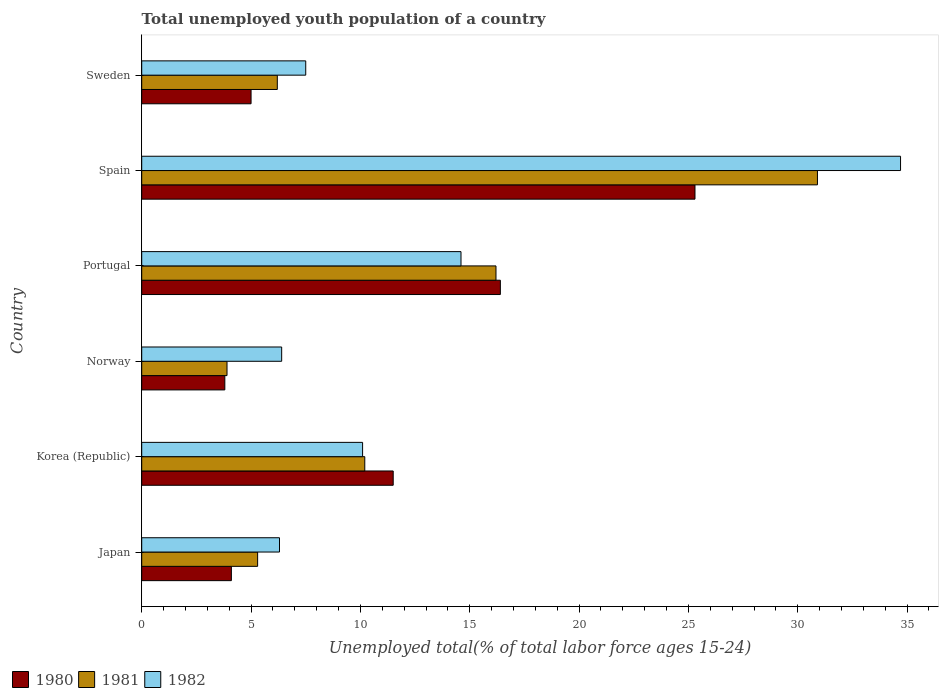Are the number of bars on each tick of the Y-axis equal?
Your answer should be compact. Yes. What is the label of the 2nd group of bars from the top?
Ensure brevity in your answer.  Spain. In how many cases, is the number of bars for a given country not equal to the number of legend labels?
Ensure brevity in your answer.  0. What is the percentage of total unemployed youth population of a country in 1980 in Spain?
Make the answer very short. 25.3. Across all countries, what is the maximum percentage of total unemployed youth population of a country in 1980?
Your answer should be compact. 25.3. Across all countries, what is the minimum percentage of total unemployed youth population of a country in 1981?
Make the answer very short. 3.9. In which country was the percentage of total unemployed youth population of a country in 1981 minimum?
Make the answer very short. Norway. What is the total percentage of total unemployed youth population of a country in 1981 in the graph?
Ensure brevity in your answer.  72.7. What is the difference between the percentage of total unemployed youth population of a country in 1980 in Norway and that in Sweden?
Provide a short and direct response. -1.2. What is the difference between the percentage of total unemployed youth population of a country in 1980 in Japan and the percentage of total unemployed youth population of a country in 1981 in Korea (Republic)?
Your answer should be compact. -6.1. What is the average percentage of total unemployed youth population of a country in 1981 per country?
Ensure brevity in your answer.  12.12. What is the difference between the percentage of total unemployed youth population of a country in 1981 and percentage of total unemployed youth population of a country in 1980 in Sweden?
Offer a very short reply. 1.2. In how many countries, is the percentage of total unemployed youth population of a country in 1982 greater than 3 %?
Make the answer very short. 6. What is the ratio of the percentage of total unemployed youth population of a country in 1981 in Japan to that in Norway?
Your answer should be compact. 1.36. What is the difference between the highest and the second highest percentage of total unemployed youth population of a country in 1980?
Provide a short and direct response. 8.9. What is the difference between the highest and the lowest percentage of total unemployed youth population of a country in 1981?
Provide a succinct answer. 27. In how many countries, is the percentage of total unemployed youth population of a country in 1981 greater than the average percentage of total unemployed youth population of a country in 1981 taken over all countries?
Your answer should be compact. 2. Is the sum of the percentage of total unemployed youth population of a country in 1981 in Norway and Spain greater than the maximum percentage of total unemployed youth population of a country in 1980 across all countries?
Offer a terse response. Yes. What does the 2nd bar from the top in Japan represents?
Your answer should be very brief. 1981. How many bars are there?
Offer a very short reply. 18. Are all the bars in the graph horizontal?
Ensure brevity in your answer.  Yes. Are the values on the major ticks of X-axis written in scientific E-notation?
Your response must be concise. No. Does the graph contain grids?
Provide a short and direct response. No. Where does the legend appear in the graph?
Keep it short and to the point. Bottom left. How are the legend labels stacked?
Offer a very short reply. Horizontal. What is the title of the graph?
Your answer should be very brief. Total unemployed youth population of a country. What is the label or title of the X-axis?
Offer a very short reply. Unemployed total(% of total labor force ages 15-24). What is the Unemployed total(% of total labor force ages 15-24) in 1980 in Japan?
Your answer should be very brief. 4.1. What is the Unemployed total(% of total labor force ages 15-24) in 1981 in Japan?
Your response must be concise. 5.3. What is the Unemployed total(% of total labor force ages 15-24) of 1982 in Japan?
Make the answer very short. 6.3. What is the Unemployed total(% of total labor force ages 15-24) of 1980 in Korea (Republic)?
Offer a very short reply. 11.5. What is the Unemployed total(% of total labor force ages 15-24) of 1981 in Korea (Republic)?
Provide a short and direct response. 10.2. What is the Unemployed total(% of total labor force ages 15-24) of 1982 in Korea (Republic)?
Your answer should be compact. 10.1. What is the Unemployed total(% of total labor force ages 15-24) of 1980 in Norway?
Give a very brief answer. 3.8. What is the Unemployed total(% of total labor force ages 15-24) of 1981 in Norway?
Offer a very short reply. 3.9. What is the Unemployed total(% of total labor force ages 15-24) of 1982 in Norway?
Your answer should be compact. 6.4. What is the Unemployed total(% of total labor force ages 15-24) of 1980 in Portugal?
Your answer should be compact. 16.4. What is the Unemployed total(% of total labor force ages 15-24) in 1981 in Portugal?
Your response must be concise. 16.2. What is the Unemployed total(% of total labor force ages 15-24) in 1982 in Portugal?
Provide a short and direct response. 14.6. What is the Unemployed total(% of total labor force ages 15-24) in 1980 in Spain?
Give a very brief answer. 25.3. What is the Unemployed total(% of total labor force ages 15-24) in 1981 in Spain?
Ensure brevity in your answer.  30.9. What is the Unemployed total(% of total labor force ages 15-24) of 1982 in Spain?
Make the answer very short. 34.7. What is the Unemployed total(% of total labor force ages 15-24) of 1981 in Sweden?
Give a very brief answer. 6.2. What is the Unemployed total(% of total labor force ages 15-24) of 1982 in Sweden?
Give a very brief answer. 7.5. Across all countries, what is the maximum Unemployed total(% of total labor force ages 15-24) in 1980?
Offer a very short reply. 25.3. Across all countries, what is the maximum Unemployed total(% of total labor force ages 15-24) in 1981?
Keep it short and to the point. 30.9. Across all countries, what is the maximum Unemployed total(% of total labor force ages 15-24) in 1982?
Your answer should be compact. 34.7. Across all countries, what is the minimum Unemployed total(% of total labor force ages 15-24) in 1980?
Your response must be concise. 3.8. Across all countries, what is the minimum Unemployed total(% of total labor force ages 15-24) of 1981?
Your answer should be very brief. 3.9. Across all countries, what is the minimum Unemployed total(% of total labor force ages 15-24) of 1982?
Provide a short and direct response. 6.3. What is the total Unemployed total(% of total labor force ages 15-24) of 1980 in the graph?
Your answer should be very brief. 66.1. What is the total Unemployed total(% of total labor force ages 15-24) of 1981 in the graph?
Keep it short and to the point. 72.7. What is the total Unemployed total(% of total labor force ages 15-24) in 1982 in the graph?
Offer a terse response. 79.6. What is the difference between the Unemployed total(% of total labor force ages 15-24) in 1980 in Japan and that in Korea (Republic)?
Offer a terse response. -7.4. What is the difference between the Unemployed total(% of total labor force ages 15-24) in 1982 in Japan and that in Korea (Republic)?
Your answer should be compact. -3.8. What is the difference between the Unemployed total(% of total labor force ages 15-24) in 1980 in Japan and that in Norway?
Ensure brevity in your answer.  0.3. What is the difference between the Unemployed total(% of total labor force ages 15-24) of 1981 in Japan and that in Norway?
Offer a very short reply. 1.4. What is the difference between the Unemployed total(% of total labor force ages 15-24) of 1982 in Japan and that in Norway?
Your answer should be very brief. -0.1. What is the difference between the Unemployed total(% of total labor force ages 15-24) in 1982 in Japan and that in Portugal?
Your answer should be very brief. -8.3. What is the difference between the Unemployed total(% of total labor force ages 15-24) in 1980 in Japan and that in Spain?
Keep it short and to the point. -21.2. What is the difference between the Unemployed total(% of total labor force ages 15-24) of 1981 in Japan and that in Spain?
Make the answer very short. -25.6. What is the difference between the Unemployed total(% of total labor force ages 15-24) in 1982 in Japan and that in Spain?
Provide a succinct answer. -28.4. What is the difference between the Unemployed total(% of total labor force ages 15-24) of 1981 in Japan and that in Sweden?
Give a very brief answer. -0.9. What is the difference between the Unemployed total(% of total labor force ages 15-24) in 1981 in Korea (Republic) and that in Norway?
Offer a terse response. 6.3. What is the difference between the Unemployed total(% of total labor force ages 15-24) in 1982 in Korea (Republic) and that in Norway?
Ensure brevity in your answer.  3.7. What is the difference between the Unemployed total(% of total labor force ages 15-24) in 1982 in Korea (Republic) and that in Portugal?
Offer a very short reply. -4.5. What is the difference between the Unemployed total(% of total labor force ages 15-24) of 1981 in Korea (Republic) and that in Spain?
Provide a short and direct response. -20.7. What is the difference between the Unemployed total(% of total labor force ages 15-24) in 1982 in Korea (Republic) and that in Spain?
Ensure brevity in your answer.  -24.6. What is the difference between the Unemployed total(% of total labor force ages 15-24) of 1980 in Korea (Republic) and that in Sweden?
Offer a very short reply. 6.5. What is the difference between the Unemployed total(% of total labor force ages 15-24) in 1981 in Korea (Republic) and that in Sweden?
Your answer should be compact. 4. What is the difference between the Unemployed total(% of total labor force ages 15-24) in 1982 in Korea (Republic) and that in Sweden?
Provide a succinct answer. 2.6. What is the difference between the Unemployed total(% of total labor force ages 15-24) of 1980 in Norway and that in Portugal?
Provide a succinct answer. -12.6. What is the difference between the Unemployed total(% of total labor force ages 15-24) of 1981 in Norway and that in Portugal?
Ensure brevity in your answer.  -12.3. What is the difference between the Unemployed total(% of total labor force ages 15-24) of 1982 in Norway and that in Portugal?
Offer a very short reply. -8.2. What is the difference between the Unemployed total(% of total labor force ages 15-24) in 1980 in Norway and that in Spain?
Ensure brevity in your answer.  -21.5. What is the difference between the Unemployed total(% of total labor force ages 15-24) in 1982 in Norway and that in Spain?
Provide a short and direct response. -28.3. What is the difference between the Unemployed total(% of total labor force ages 15-24) of 1980 in Norway and that in Sweden?
Your response must be concise. -1.2. What is the difference between the Unemployed total(% of total labor force ages 15-24) of 1980 in Portugal and that in Spain?
Keep it short and to the point. -8.9. What is the difference between the Unemployed total(% of total labor force ages 15-24) of 1981 in Portugal and that in Spain?
Provide a short and direct response. -14.7. What is the difference between the Unemployed total(% of total labor force ages 15-24) in 1982 in Portugal and that in Spain?
Offer a terse response. -20.1. What is the difference between the Unemployed total(% of total labor force ages 15-24) of 1981 in Portugal and that in Sweden?
Keep it short and to the point. 10. What is the difference between the Unemployed total(% of total labor force ages 15-24) in 1980 in Spain and that in Sweden?
Give a very brief answer. 20.3. What is the difference between the Unemployed total(% of total labor force ages 15-24) in 1981 in Spain and that in Sweden?
Your response must be concise. 24.7. What is the difference between the Unemployed total(% of total labor force ages 15-24) of 1982 in Spain and that in Sweden?
Keep it short and to the point. 27.2. What is the difference between the Unemployed total(% of total labor force ages 15-24) of 1981 in Japan and the Unemployed total(% of total labor force ages 15-24) of 1982 in Portugal?
Give a very brief answer. -9.3. What is the difference between the Unemployed total(% of total labor force ages 15-24) of 1980 in Japan and the Unemployed total(% of total labor force ages 15-24) of 1981 in Spain?
Your answer should be very brief. -26.8. What is the difference between the Unemployed total(% of total labor force ages 15-24) in 1980 in Japan and the Unemployed total(% of total labor force ages 15-24) in 1982 in Spain?
Offer a very short reply. -30.6. What is the difference between the Unemployed total(% of total labor force ages 15-24) in 1981 in Japan and the Unemployed total(% of total labor force ages 15-24) in 1982 in Spain?
Provide a succinct answer. -29.4. What is the difference between the Unemployed total(% of total labor force ages 15-24) of 1981 in Japan and the Unemployed total(% of total labor force ages 15-24) of 1982 in Sweden?
Your answer should be very brief. -2.2. What is the difference between the Unemployed total(% of total labor force ages 15-24) of 1980 in Korea (Republic) and the Unemployed total(% of total labor force ages 15-24) of 1981 in Norway?
Ensure brevity in your answer.  7.6. What is the difference between the Unemployed total(% of total labor force ages 15-24) in 1981 in Korea (Republic) and the Unemployed total(% of total labor force ages 15-24) in 1982 in Norway?
Your answer should be compact. 3.8. What is the difference between the Unemployed total(% of total labor force ages 15-24) in 1980 in Korea (Republic) and the Unemployed total(% of total labor force ages 15-24) in 1982 in Portugal?
Give a very brief answer. -3.1. What is the difference between the Unemployed total(% of total labor force ages 15-24) in 1980 in Korea (Republic) and the Unemployed total(% of total labor force ages 15-24) in 1981 in Spain?
Keep it short and to the point. -19.4. What is the difference between the Unemployed total(% of total labor force ages 15-24) in 1980 in Korea (Republic) and the Unemployed total(% of total labor force ages 15-24) in 1982 in Spain?
Make the answer very short. -23.2. What is the difference between the Unemployed total(% of total labor force ages 15-24) of 1981 in Korea (Republic) and the Unemployed total(% of total labor force ages 15-24) of 1982 in Spain?
Offer a terse response. -24.5. What is the difference between the Unemployed total(% of total labor force ages 15-24) in 1980 in Korea (Republic) and the Unemployed total(% of total labor force ages 15-24) in 1981 in Sweden?
Make the answer very short. 5.3. What is the difference between the Unemployed total(% of total labor force ages 15-24) of 1980 in Korea (Republic) and the Unemployed total(% of total labor force ages 15-24) of 1982 in Sweden?
Keep it short and to the point. 4. What is the difference between the Unemployed total(% of total labor force ages 15-24) in 1981 in Korea (Republic) and the Unemployed total(% of total labor force ages 15-24) in 1982 in Sweden?
Your response must be concise. 2.7. What is the difference between the Unemployed total(% of total labor force ages 15-24) in 1980 in Norway and the Unemployed total(% of total labor force ages 15-24) in 1981 in Portugal?
Ensure brevity in your answer.  -12.4. What is the difference between the Unemployed total(% of total labor force ages 15-24) in 1980 in Norway and the Unemployed total(% of total labor force ages 15-24) in 1982 in Portugal?
Ensure brevity in your answer.  -10.8. What is the difference between the Unemployed total(% of total labor force ages 15-24) in 1981 in Norway and the Unemployed total(% of total labor force ages 15-24) in 1982 in Portugal?
Your response must be concise. -10.7. What is the difference between the Unemployed total(% of total labor force ages 15-24) in 1980 in Norway and the Unemployed total(% of total labor force ages 15-24) in 1981 in Spain?
Give a very brief answer. -27.1. What is the difference between the Unemployed total(% of total labor force ages 15-24) in 1980 in Norway and the Unemployed total(% of total labor force ages 15-24) in 1982 in Spain?
Offer a terse response. -30.9. What is the difference between the Unemployed total(% of total labor force ages 15-24) of 1981 in Norway and the Unemployed total(% of total labor force ages 15-24) of 1982 in Spain?
Make the answer very short. -30.8. What is the difference between the Unemployed total(% of total labor force ages 15-24) in 1980 in Portugal and the Unemployed total(% of total labor force ages 15-24) in 1981 in Spain?
Offer a terse response. -14.5. What is the difference between the Unemployed total(% of total labor force ages 15-24) of 1980 in Portugal and the Unemployed total(% of total labor force ages 15-24) of 1982 in Spain?
Provide a succinct answer. -18.3. What is the difference between the Unemployed total(% of total labor force ages 15-24) of 1981 in Portugal and the Unemployed total(% of total labor force ages 15-24) of 1982 in Spain?
Give a very brief answer. -18.5. What is the difference between the Unemployed total(% of total labor force ages 15-24) of 1981 in Portugal and the Unemployed total(% of total labor force ages 15-24) of 1982 in Sweden?
Offer a terse response. 8.7. What is the difference between the Unemployed total(% of total labor force ages 15-24) of 1980 in Spain and the Unemployed total(% of total labor force ages 15-24) of 1982 in Sweden?
Your answer should be compact. 17.8. What is the difference between the Unemployed total(% of total labor force ages 15-24) in 1981 in Spain and the Unemployed total(% of total labor force ages 15-24) in 1982 in Sweden?
Provide a short and direct response. 23.4. What is the average Unemployed total(% of total labor force ages 15-24) in 1980 per country?
Offer a very short reply. 11.02. What is the average Unemployed total(% of total labor force ages 15-24) in 1981 per country?
Your response must be concise. 12.12. What is the average Unemployed total(% of total labor force ages 15-24) in 1982 per country?
Your answer should be compact. 13.27. What is the difference between the Unemployed total(% of total labor force ages 15-24) in 1980 and Unemployed total(% of total labor force ages 15-24) in 1981 in Japan?
Provide a short and direct response. -1.2. What is the difference between the Unemployed total(% of total labor force ages 15-24) of 1981 and Unemployed total(% of total labor force ages 15-24) of 1982 in Korea (Republic)?
Keep it short and to the point. 0.1. What is the difference between the Unemployed total(% of total labor force ages 15-24) in 1980 and Unemployed total(% of total labor force ages 15-24) in 1982 in Norway?
Offer a terse response. -2.6. What is the difference between the Unemployed total(% of total labor force ages 15-24) in 1981 and Unemployed total(% of total labor force ages 15-24) in 1982 in Norway?
Your answer should be compact. -2.5. What is the difference between the Unemployed total(% of total labor force ages 15-24) of 1980 and Unemployed total(% of total labor force ages 15-24) of 1982 in Spain?
Keep it short and to the point. -9.4. What is the difference between the Unemployed total(% of total labor force ages 15-24) of 1981 and Unemployed total(% of total labor force ages 15-24) of 1982 in Spain?
Your response must be concise. -3.8. What is the difference between the Unemployed total(% of total labor force ages 15-24) of 1980 and Unemployed total(% of total labor force ages 15-24) of 1981 in Sweden?
Your answer should be very brief. -1.2. What is the difference between the Unemployed total(% of total labor force ages 15-24) of 1980 and Unemployed total(% of total labor force ages 15-24) of 1982 in Sweden?
Ensure brevity in your answer.  -2.5. What is the ratio of the Unemployed total(% of total labor force ages 15-24) in 1980 in Japan to that in Korea (Republic)?
Provide a short and direct response. 0.36. What is the ratio of the Unemployed total(% of total labor force ages 15-24) in 1981 in Japan to that in Korea (Republic)?
Your answer should be compact. 0.52. What is the ratio of the Unemployed total(% of total labor force ages 15-24) in 1982 in Japan to that in Korea (Republic)?
Provide a short and direct response. 0.62. What is the ratio of the Unemployed total(% of total labor force ages 15-24) of 1980 in Japan to that in Norway?
Provide a short and direct response. 1.08. What is the ratio of the Unemployed total(% of total labor force ages 15-24) of 1981 in Japan to that in Norway?
Ensure brevity in your answer.  1.36. What is the ratio of the Unemployed total(% of total labor force ages 15-24) in 1982 in Japan to that in Norway?
Your answer should be very brief. 0.98. What is the ratio of the Unemployed total(% of total labor force ages 15-24) of 1980 in Japan to that in Portugal?
Ensure brevity in your answer.  0.25. What is the ratio of the Unemployed total(% of total labor force ages 15-24) of 1981 in Japan to that in Portugal?
Give a very brief answer. 0.33. What is the ratio of the Unemployed total(% of total labor force ages 15-24) of 1982 in Japan to that in Portugal?
Make the answer very short. 0.43. What is the ratio of the Unemployed total(% of total labor force ages 15-24) in 1980 in Japan to that in Spain?
Your response must be concise. 0.16. What is the ratio of the Unemployed total(% of total labor force ages 15-24) in 1981 in Japan to that in Spain?
Ensure brevity in your answer.  0.17. What is the ratio of the Unemployed total(% of total labor force ages 15-24) of 1982 in Japan to that in Spain?
Provide a succinct answer. 0.18. What is the ratio of the Unemployed total(% of total labor force ages 15-24) of 1980 in Japan to that in Sweden?
Your response must be concise. 0.82. What is the ratio of the Unemployed total(% of total labor force ages 15-24) of 1981 in Japan to that in Sweden?
Give a very brief answer. 0.85. What is the ratio of the Unemployed total(% of total labor force ages 15-24) in 1982 in Japan to that in Sweden?
Give a very brief answer. 0.84. What is the ratio of the Unemployed total(% of total labor force ages 15-24) in 1980 in Korea (Republic) to that in Norway?
Your answer should be compact. 3.03. What is the ratio of the Unemployed total(% of total labor force ages 15-24) in 1981 in Korea (Republic) to that in Norway?
Your response must be concise. 2.62. What is the ratio of the Unemployed total(% of total labor force ages 15-24) in 1982 in Korea (Republic) to that in Norway?
Make the answer very short. 1.58. What is the ratio of the Unemployed total(% of total labor force ages 15-24) of 1980 in Korea (Republic) to that in Portugal?
Make the answer very short. 0.7. What is the ratio of the Unemployed total(% of total labor force ages 15-24) of 1981 in Korea (Republic) to that in Portugal?
Provide a short and direct response. 0.63. What is the ratio of the Unemployed total(% of total labor force ages 15-24) in 1982 in Korea (Republic) to that in Portugal?
Offer a very short reply. 0.69. What is the ratio of the Unemployed total(% of total labor force ages 15-24) in 1980 in Korea (Republic) to that in Spain?
Provide a short and direct response. 0.45. What is the ratio of the Unemployed total(% of total labor force ages 15-24) in 1981 in Korea (Republic) to that in Spain?
Provide a succinct answer. 0.33. What is the ratio of the Unemployed total(% of total labor force ages 15-24) of 1982 in Korea (Republic) to that in Spain?
Offer a terse response. 0.29. What is the ratio of the Unemployed total(% of total labor force ages 15-24) in 1981 in Korea (Republic) to that in Sweden?
Offer a very short reply. 1.65. What is the ratio of the Unemployed total(% of total labor force ages 15-24) of 1982 in Korea (Republic) to that in Sweden?
Ensure brevity in your answer.  1.35. What is the ratio of the Unemployed total(% of total labor force ages 15-24) in 1980 in Norway to that in Portugal?
Your answer should be compact. 0.23. What is the ratio of the Unemployed total(% of total labor force ages 15-24) in 1981 in Norway to that in Portugal?
Provide a short and direct response. 0.24. What is the ratio of the Unemployed total(% of total labor force ages 15-24) of 1982 in Norway to that in Portugal?
Your answer should be compact. 0.44. What is the ratio of the Unemployed total(% of total labor force ages 15-24) in 1980 in Norway to that in Spain?
Your answer should be very brief. 0.15. What is the ratio of the Unemployed total(% of total labor force ages 15-24) of 1981 in Norway to that in Spain?
Ensure brevity in your answer.  0.13. What is the ratio of the Unemployed total(% of total labor force ages 15-24) of 1982 in Norway to that in Spain?
Your response must be concise. 0.18. What is the ratio of the Unemployed total(% of total labor force ages 15-24) of 1980 in Norway to that in Sweden?
Provide a short and direct response. 0.76. What is the ratio of the Unemployed total(% of total labor force ages 15-24) of 1981 in Norway to that in Sweden?
Offer a terse response. 0.63. What is the ratio of the Unemployed total(% of total labor force ages 15-24) in 1982 in Norway to that in Sweden?
Provide a short and direct response. 0.85. What is the ratio of the Unemployed total(% of total labor force ages 15-24) of 1980 in Portugal to that in Spain?
Your answer should be compact. 0.65. What is the ratio of the Unemployed total(% of total labor force ages 15-24) of 1981 in Portugal to that in Spain?
Make the answer very short. 0.52. What is the ratio of the Unemployed total(% of total labor force ages 15-24) in 1982 in Portugal to that in Spain?
Ensure brevity in your answer.  0.42. What is the ratio of the Unemployed total(% of total labor force ages 15-24) of 1980 in Portugal to that in Sweden?
Provide a short and direct response. 3.28. What is the ratio of the Unemployed total(% of total labor force ages 15-24) of 1981 in Portugal to that in Sweden?
Provide a short and direct response. 2.61. What is the ratio of the Unemployed total(% of total labor force ages 15-24) in 1982 in Portugal to that in Sweden?
Give a very brief answer. 1.95. What is the ratio of the Unemployed total(% of total labor force ages 15-24) in 1980 in Spain to that in Sweden?
Your answer should be compact. 5.06. What is the ratio of the Unemployed total(% of total labor force ages 15-24) of 1981 in Spain to that in Sweden?
Keep it short and to the point. 4.98. What is the ratio of the Unemployed total(% of total labor force ages 15-24) of 1982 in Spain to that in Sweden?
Provide a short and direct response. 4.63. What is the difference between the highest and the second highest Unemployed total(% of total labor force ages 15-24) of 1982?
Your answer should be very brief. 20.1. What is the difference between the highest and the lowest Unemployed total(% of total labor force ages 15-24) in 1980?
Provide a succinct answer. 21.5. What is the difference between the highest and the lowest Unemployed total(% of total labor force ages 15-24) in 1982?
Offer a terse response. 28.4. 